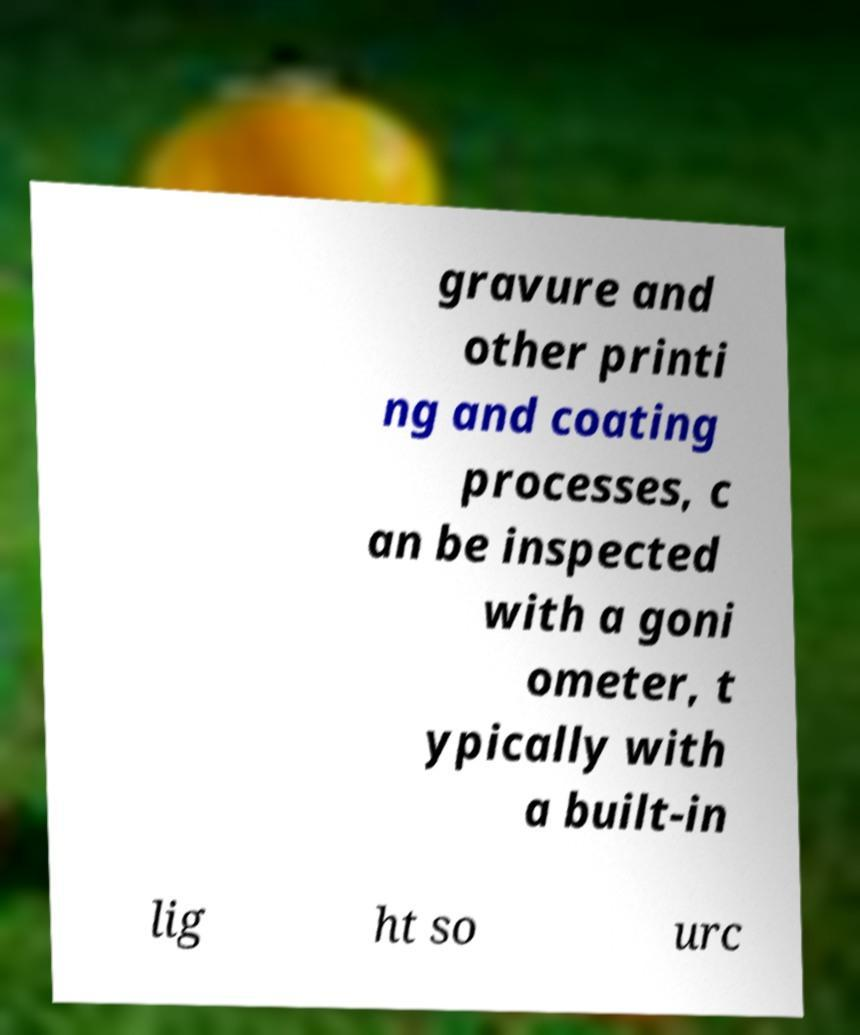Can you read and provide the text displayed in the image?This photo seems to have some interesting text. Can you extract and type it out for me? gravure and other printi ng and coating processes, c an be inspected with a goni ometer, t ypically with a built-in lig ht so urc 